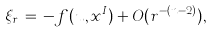<formula> <loc_0><loc_0><loc_500><loc_500>\xi _ { r } \, = \, - f ( u , x ^ { I } ) + O ( r ^ { - ( n - 2 ) } ) ,</formula> 